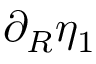Convert formula to latex. <formula><loc_0><loc_0><loc_500><loc_500>\partial _ { R } \eta _ { 1 }</formula> 